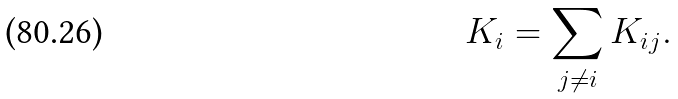<formula> <loc_0><loc_0><loc_500><loc_500>K _ { i } = \sum _ { j \not = i } K _ { i j } .</formula> 